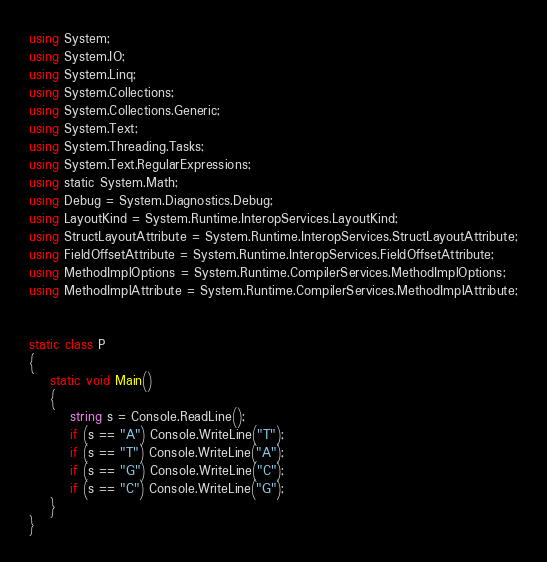<code> <loc_0><loc_0><loc_500><loc_500><_C#_>using System;
using System.IO;
using System.Linq;
using System.Collections;
using System.Collections.Generic;
using System.Text;
using System.Threading.Tasks;
using System.Text.RegularExpressions;
using static System.Math;
using Debug = System.Diagnostics.Debug;
using LayoutKind = System.Runtime.InteropServices.LayoutKind;
using StructLayoutAttribute = System.Runtime.InteropServices.StructLayoutAttribute;
using FieldOffsetAttribute = System.Runtime.InteropServices.FieldOffsetAttribute;
using MethodImplOptions = System.Runtime.CompilerServices.MethodImplOptions;
using MethodImplAttribute = System.Runtime.CompilerServices.MethodImplAttribute;


static class P
{
    static void Main()
    {
        string s = Console.ReadLine();
        if (s == "A") Console.WriteLine("T");
        if (s == "T") Console.WriteLine("A");
        if (s == "G") Console.WriteLine("C");
        if (s == "C") Console.WriteLine("G");
    }
}
</code> 